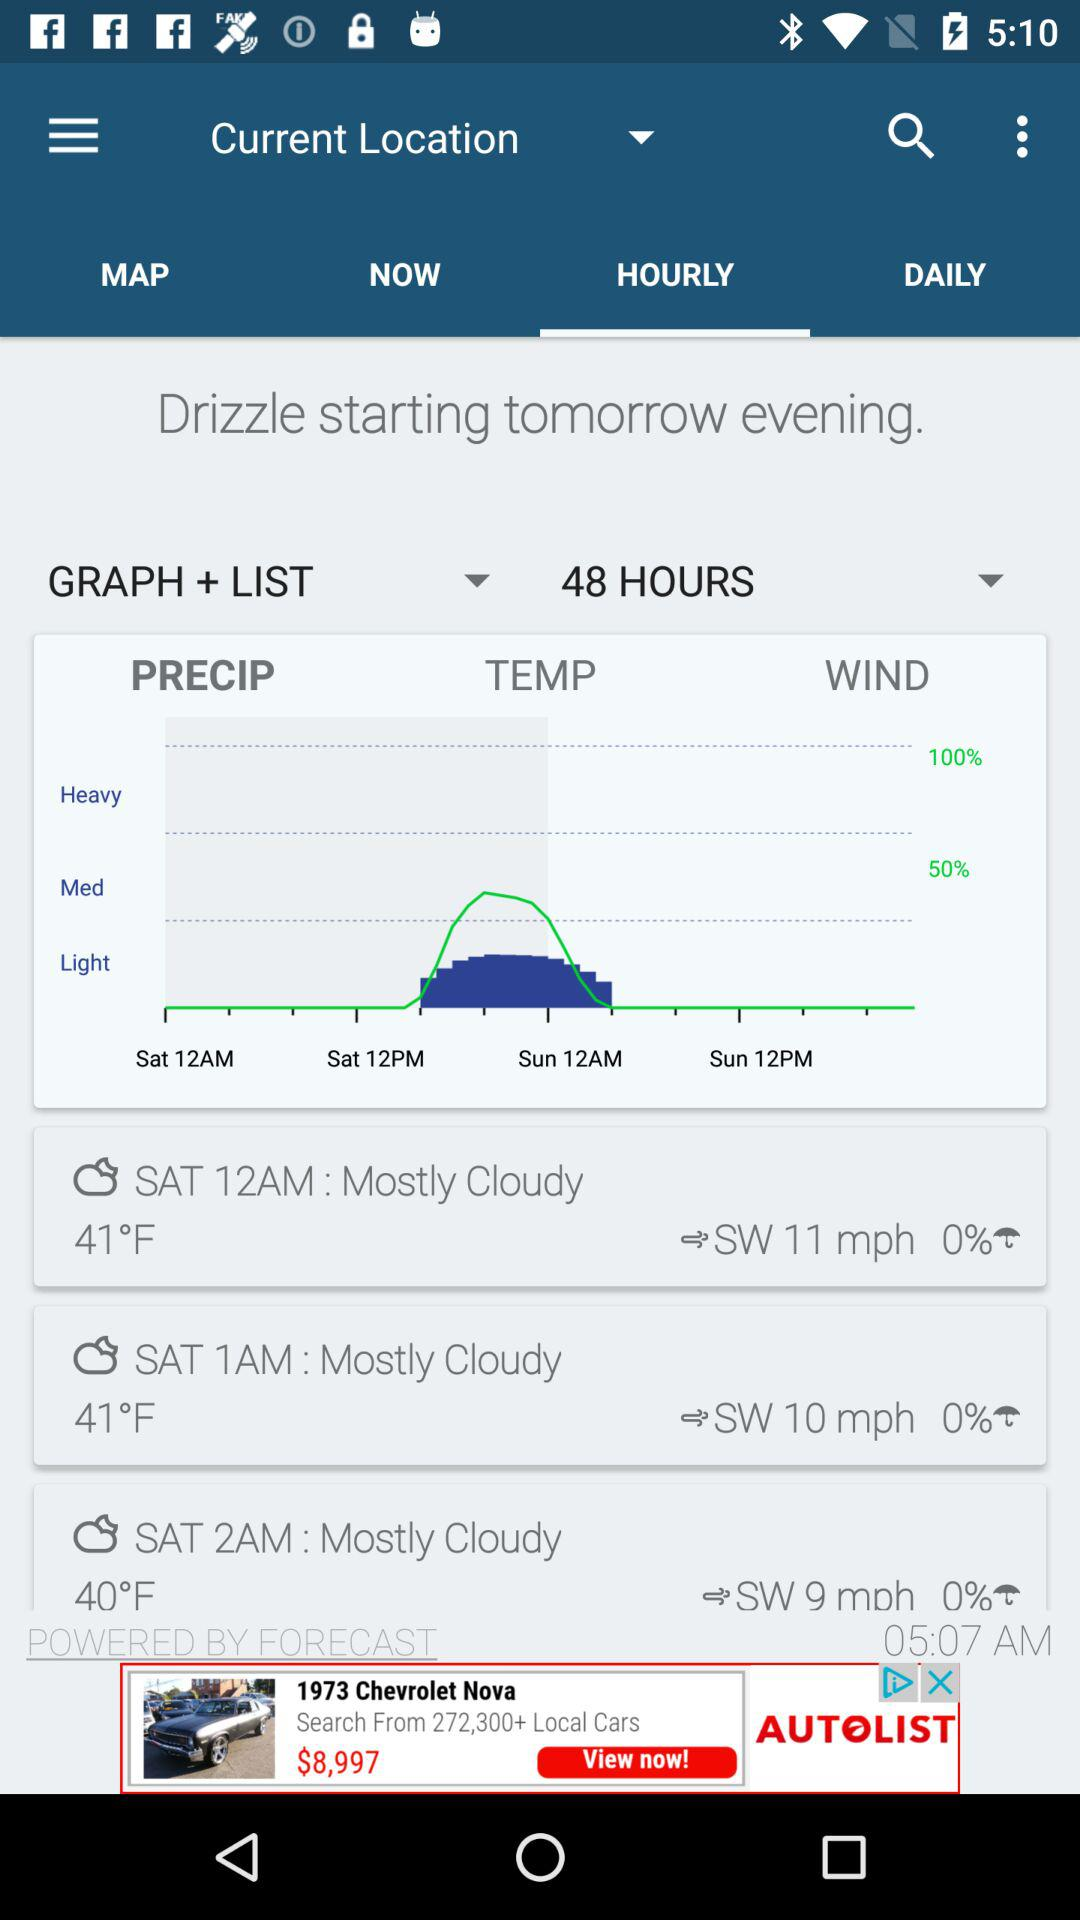What is the difference in temperature between the lowest and highest temperatures shown? The temperature displayed on the graph peaks at approximately 50°F around midday and reaches a low near 40°F during the early hours, resulting in a temperature difference of about 10°F between the highest and lowest temperatures shown. 